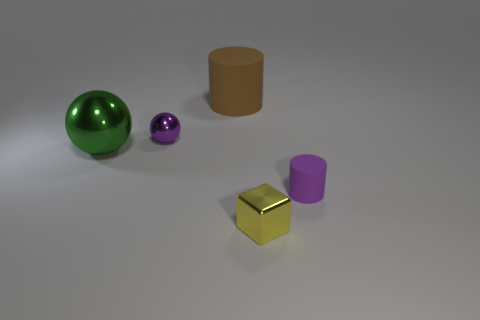Does the large shiny sphere have the same color as the tiny matte object?
Give a very brief answer. No. There is a metal thing to the right of the small purple object that is behind the big thing that is in front of the large brown thing; how big is it?
Your answer should be compact. Small. What shape is the small purple object to the left of the cylinder to the left of the metallic block?
Your response must be concise. Sphere. There is a tiny metal thing that is behind the shiny block; is its color the same as the tiny matte thing?
Keep it short and to the point. Yes. There is a small object that is left of the tiny purple matte cylinder and behind the tiny block; what is its color?
Make the answer very short. Purple. Is there a big cylinder made of the same material as the large green object?
Offer a terse response. No. How big is the yellow metallic cube?
Ensure brevity in your answer.  Small. There is a sphere that is in front of the small purple thing behind the large sphere; how big is it?
Provide a succinct answer. Large. There is a tiny purple thing that is the same shape as the large matte thing; what is its material?
Provide a short and direct response. Rubber. How many cyan metallic blocks are there?
Give a very brief answer. 0. 